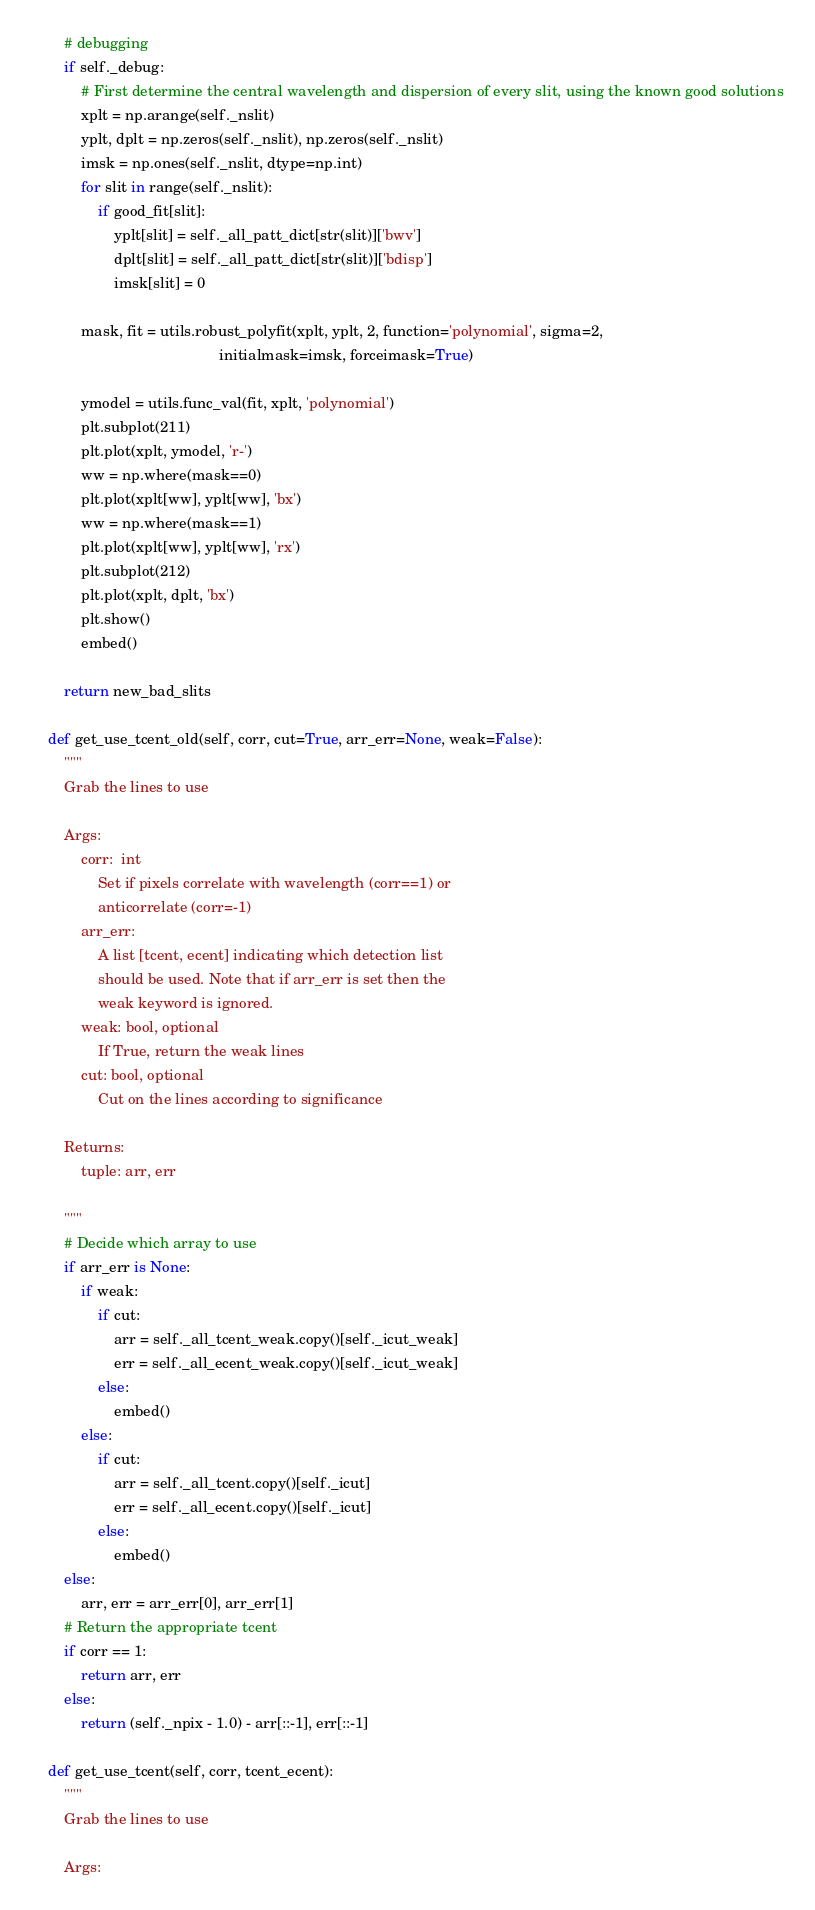Convert code to text. <code><loc_0><loc_0><loc_500><loc_500><_Python_>        # debugging
        if self._debug:
            # First determine the central wavelength and dispersion of every slit, using the known good solutions
            xplt = np.arange(self._nslit)
            yplt, dplt = np.zeros(self._nslit), np.zeros(self._nslit)
            imsk = np.ones(self._nslit, dtype=np.int)
            for slit in range(self._nslit):
                if good_fit[slit]:
                    yplt[slit] = self._all_patt_dict[str(slit)]['bwv']
                    dplt[slit] = self._all_patt_dict[str(slit)]['bdisp']
                    imsk[slit] = 0

            mask, fit = utils.robust_polyfit(xplt, yplt, 2, function='polynomial', sigma=2,
                                             initialmask=imsk, forceimask=True)

            ymodel = utils.func_val(fit, xplt, 'polynomial')
            plt.subplot(211)
            plt.plot(xplt, ymodel, 'r-')
            ww = np.where(mask==0)
            plt.plot(xplt[ww], yplt[ww], 'bx')
            ww = np.where(mask==1)
            plt.plot(xplt[ww], yplt[ww], 'rx')
            plt.subplot(212)
            plt.plot(xplt, dplt, 'bx')
            plt.show()
            embed()

        return new_bad_slits

    def get_use_tcent_old(self, corr, cut=True, arr_err=None, weak=False):
        """
        Grab the lines to use

        Args:
            corr:  int
                Set if pixels correlate with wavelength (corr==1) or
                anticorrelate (corr=-1)
            arr_err:
                A list [tcent, ecent] indicating which detection list
                should be used. Note that if arr_err is set then the
                weak keyword is ignored.
            weak: bool, optional
                If True, return the weak lines
            cut: bool, optional
                Cut on the lines according to significance

        Returns:
            tuple: arr, err

        """
        # Decide which array to use
        if arr_err is None:
            if weak:
                if cut:
                    arr = self._all_tcent_weak.copy()[self._icut_weak]
                    err = self._all_ecent_weak.copy()[self._icut_weak]
                else:
                    embed()
            else:
                if cut:
                    arr = self._all_tcent.copy()[self._icut]
                    err = self._all_ecent.copy()[self._icut]
                else:
                    embed()
        else:
            arr, err = arr_err[0], arr_err[1]
        # Return the appropriate tcent
        if corr == 1:
            return arr, err
        else:
            return (self._npix - 1.0) - arr[::-1], err[::-1]

    def get_use_tcent(self, corr, tcent_ecent):
        """
        Grab the lines to use

        Args:</code> 